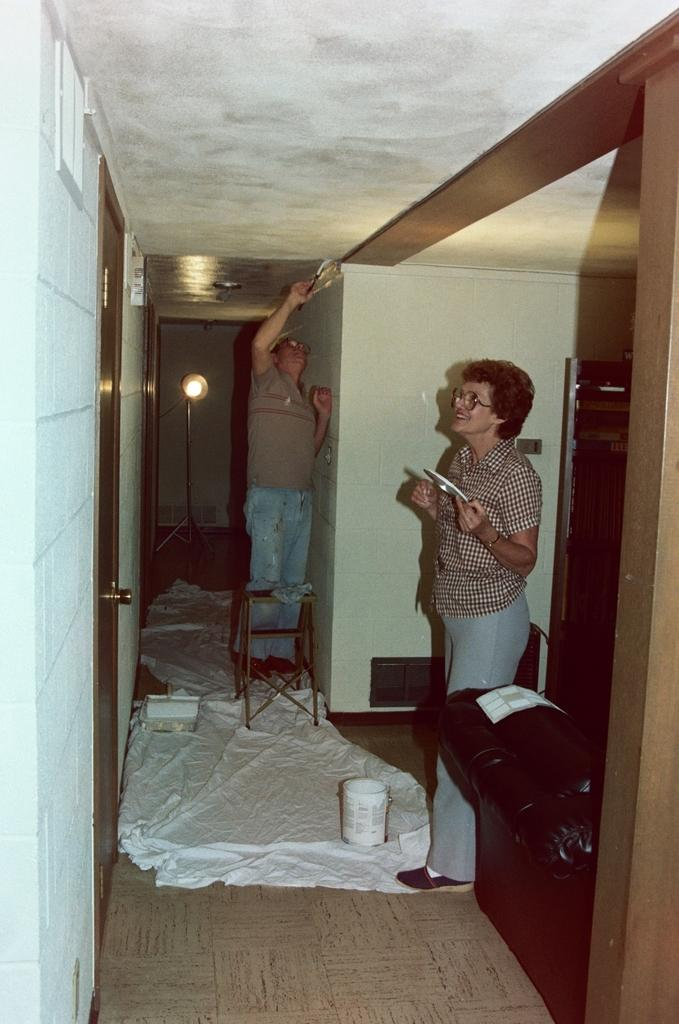How many persons are present in the image? There are two persons on the floor in the image. What is covering something in the image? There is a cover in the image. What can be seen in the background of the image? There is a wall, a light, a door, and a chair in the background of the image. What might be the location of the image based on the background? The image may have been taken in a hall. What type of writer is sitting on the chair in the background of the image? There is no writer present in the image, and the chair is in the background. Can you tell me how many rabbits are visible in the image? There are no rabbits present in the image. 